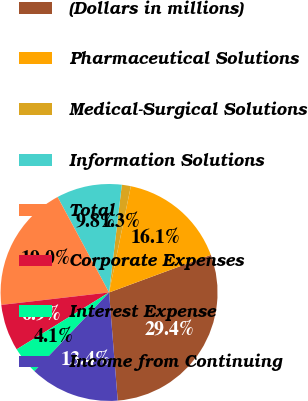Convert chart to OTSL. <chart><loc_0><loc_0><loc_500><loc_500><pie_chart><fcel>(Dollars in millions)<fcel>Pharmaceutical Solutions<fcel>Medical-Surgical Solutions<fcel>Information Solutions<fcel>Total<fcel>Corporate Expenses<fcel>Interest Expense<fcel>Income from Continuing<nl><fcel>29.36%<fcel>16.15%<fcel>1.34%<fcel>9.75%<fcel>18.96%<fcel>6.95%<fcel>4.14%<fcel>13.35%<nl></chart> 